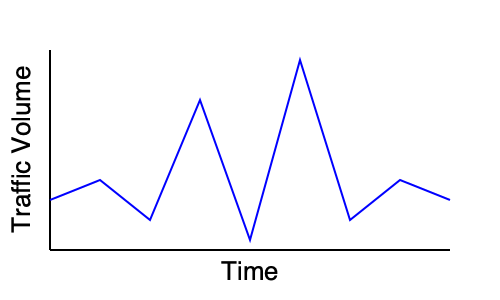Analyze the network traffic pattern shown in the time series graph. What type of network activity does this pattern most likely represent? To identify the type of network activity represented by this pattern, let's analyze the graph step-by-step:

1. Observe the overall pattern: The graph shows significant fluctuations in traffic volume over time.

2. Identify the peaks and troughs:
   - There are two prominent peaks at approximately 1/3 and 2/3 of the time axis.
   - These peaks are followed by sharp drops in traffic.

3. Analyze the periodicity:
   - The pattern seems to repeat with some regularity.
   - There are approximately 3-4 cycles visible in the given time frame.

4. Consider the shape of the peaks:
   - The peaks are sharp and sudden, indicating rapid increases in traffic.
   - The drops after the peaks are equally sudden, suggesting a quick reduction in traffic.

5. Interpret the pattern:
   - The sharp peaks followed by sudden drops are characteristic of bursty traffic.
   - This pattern is commonly associated with Distributed Denial of Service (DDoS) attacks.

6. Reasoning:
   - DDoS attacks typically involve sudden surges of traffic to overwhelm a target system.
   - The attacker may pause between bursts to evade detection or regroup resources.
   - The regularity of the pattern suggests a programmed or automated attack rather than normal network usage.

Given these observations, the most likely explanation for this network traffic pattern is a Distributed Denial of Service (DDoS) attack.
Answer: DDoS attack 